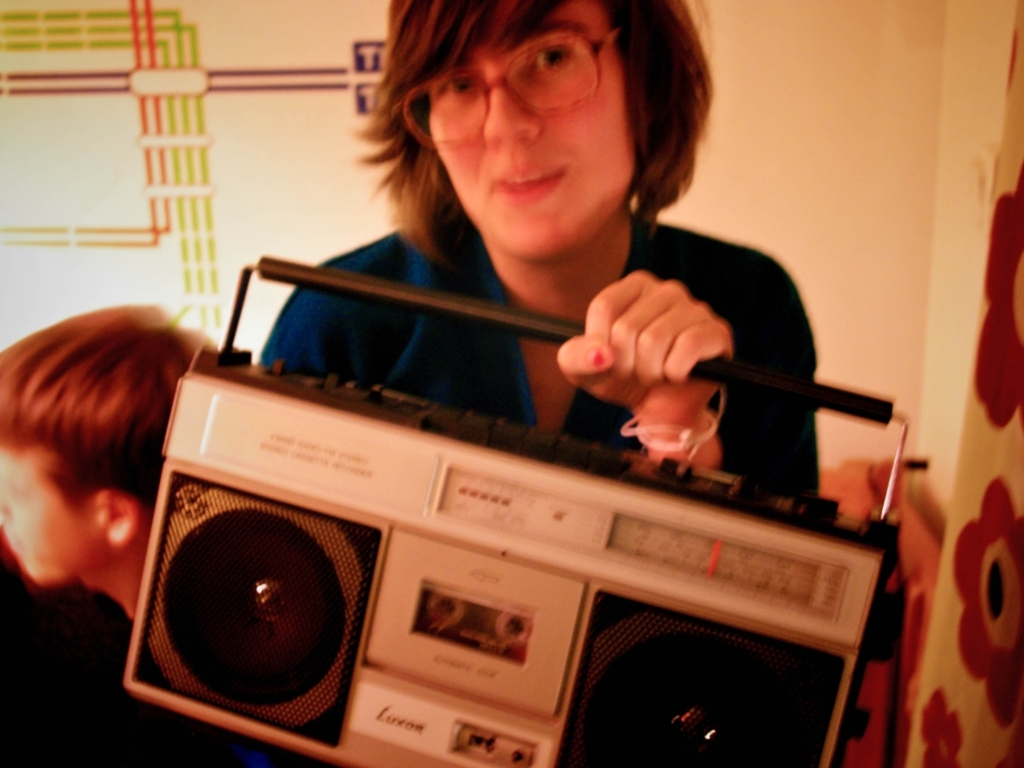What is the quality of the image? The image quality is relatively low. It appears to be taken in a dimly lit environment with a potential slight blur, possibly due to camera movement or low shutter speed. The colors are muted and the focus is not sharp, which could be indicative of an older camera model or a candid, spontaneous shot. 